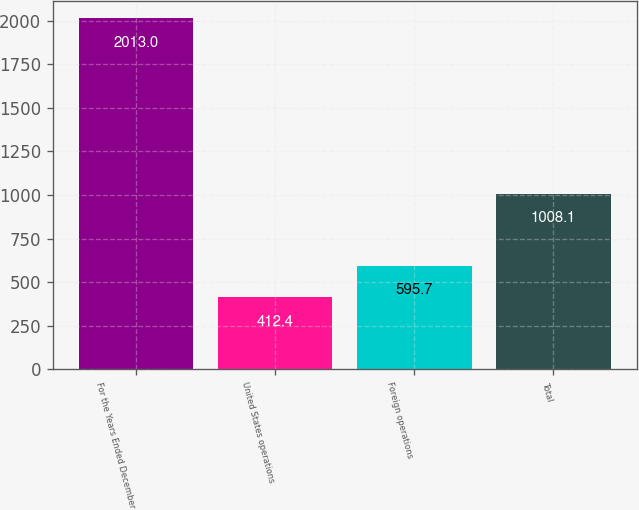<chart> <loc_0><loc_0><loc_500><loc_500><bar_chart><fcel>For the Years Ended December<fcel>United States operations<fcel>Foreign operations<fcel>Total<nl><fcel>2013<fcel>412.4<fcel>595.7<fcel>1008.1<nl></chart> 